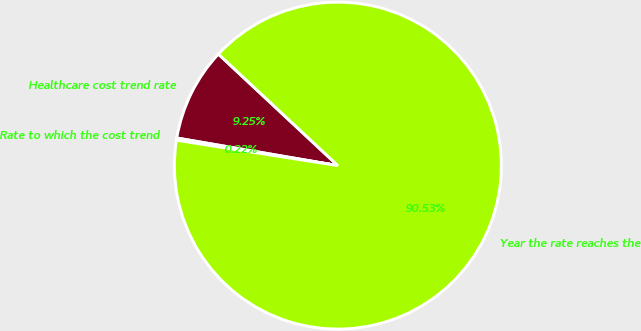Convert chart. <chart><loc_0><loc_0><loc_500><loc_500><pie_chart><fcel>Healthcare cost trend rate<fcel>Rate to which the cost trend<fcel>Year the rate reaches the<nl><fcel>9.25%<fcel>0.22%<fcel>90.52%<nl></chart> 